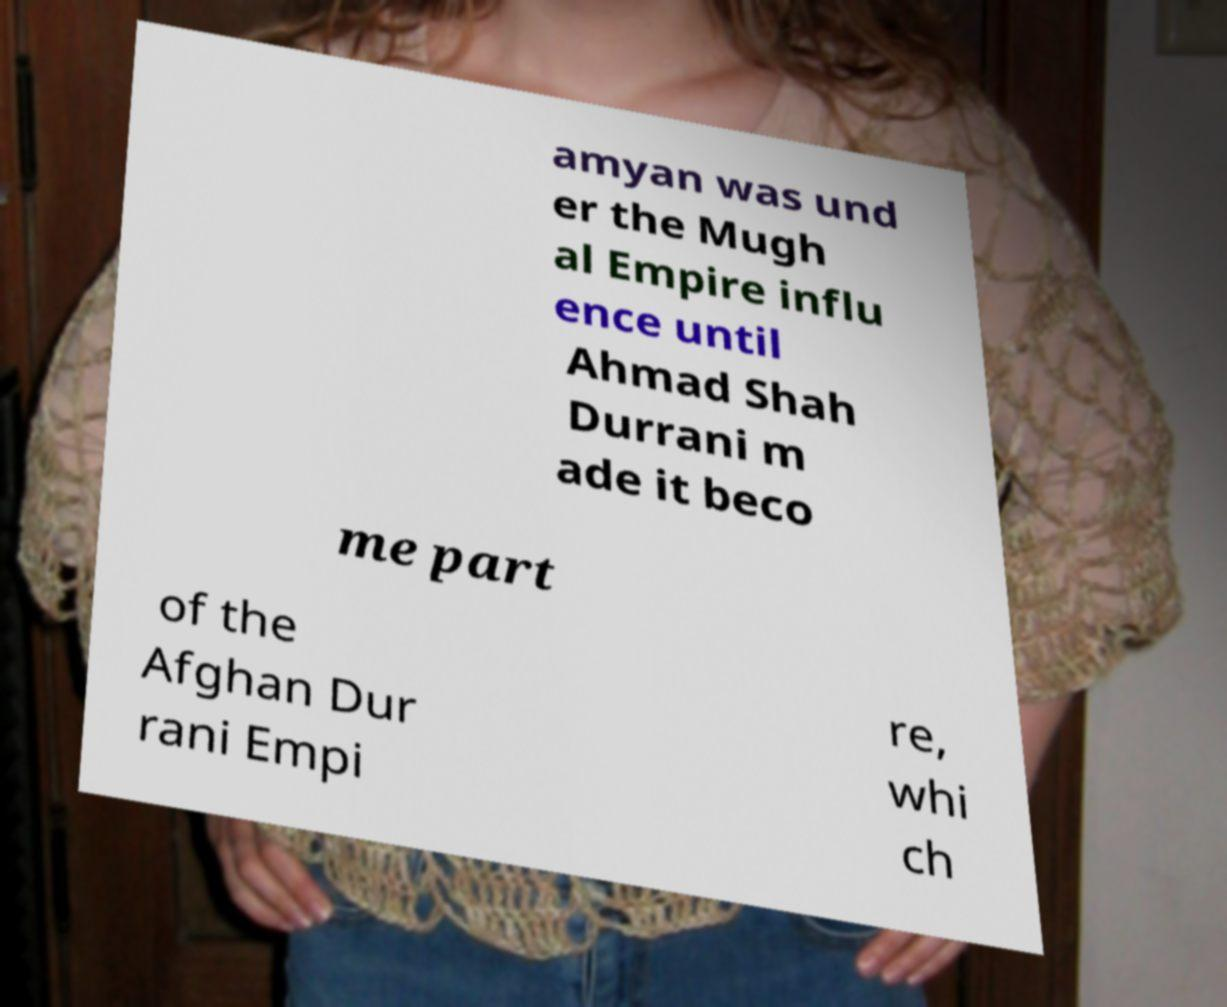Could you extract and type out the text from this image? amyan was und er the Mugh al Empire influ ence until Ahmad Shah Durrani m ade it beco me part of the Afghan Dur rani Empi re, whi ch 